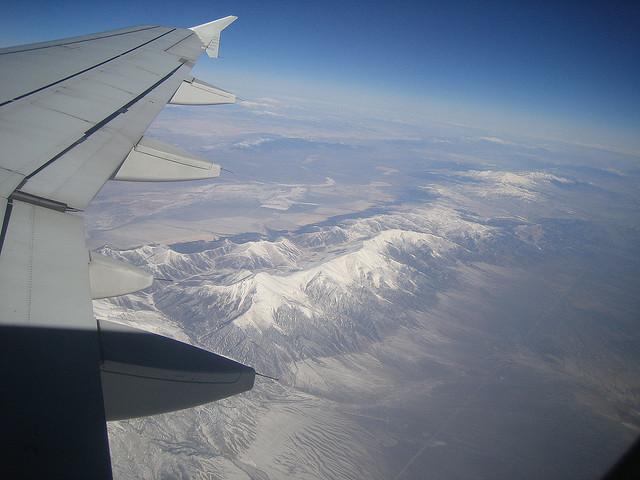Are these wings in shape?
Short answer required. Yes. Is the person taking the photo sitting near the window?
Give a very brief answer. Yes. What can be seen out of the plane window?
Concise answer only. Mountains. 